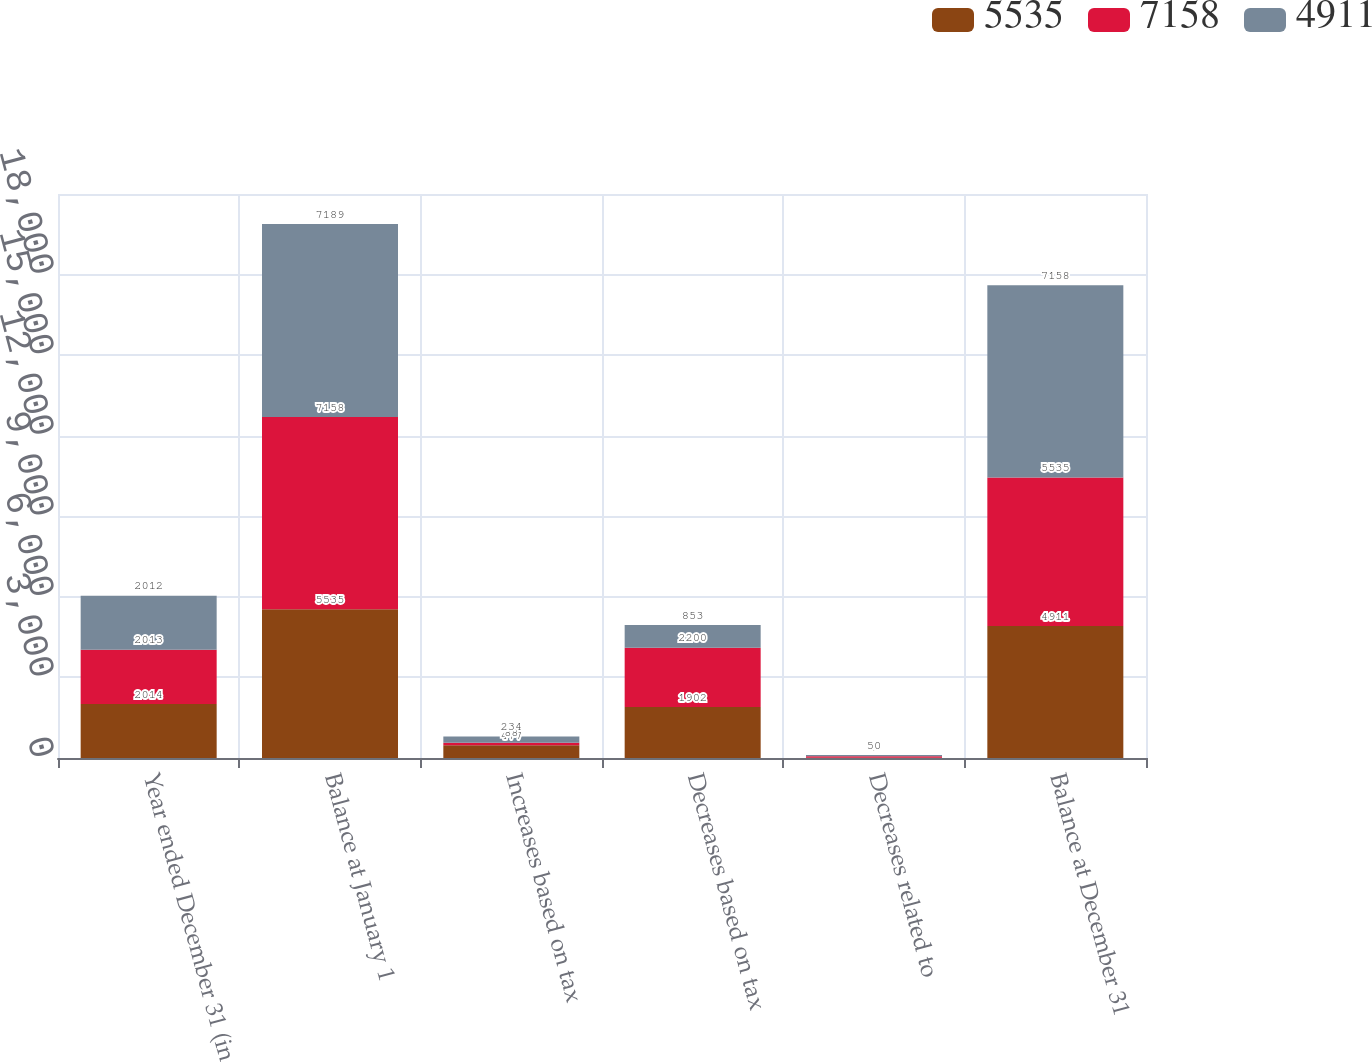Convert chart. <chart><loc_0><loc_0><loc_500><loc_500><stacked_bar_chart><ecel><fcel>Year ended December 31 (in<fcel>Balance at January 1<fcel>Increases based on tax<fcel>Decreases based on tax<fcel>Decreases related to<fcel>Balance at December 31<nl><fcel>5535<fcel>2014<fcel>5535<fcel>477<fcel>1902<fcel>9<fcel>4911<nl><fcel>7158<fcel>2013<fcel>7158<fcel>88<fcel>2200<fcel>53<fcel>5535<nl><fcel>4911<fcel>2012<fcel>7189<fcel>234<fcel>853<fcel>50<fcel>7158<nl></chart> 